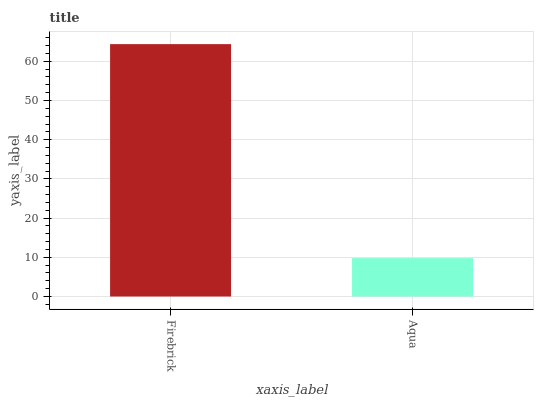Is Aqua the minimum?
Answer yes or no. Yes. Is Firebrick the maximum?
Answer yes or no. Yes. Is Aqua the maximum?
Answer yes or no. No. Is Firebrick greater than Aqua?
Answer yes or no. Yes. Is Aqua less than Firebrick?
Answer yes or no. Yes. Is Aqua greater than Firebrick?
Answer yes or no. No. Is Firebrick less than Aqua?
Answer yes or no. No. Is Firebrick the high median?
Answer yes or no. Yes. Is Aqua the low median?
Answer yes or no. Yes. Is Aqua the high median?
Answer yes or no. No. Is Firebrick the low median?
Answer yes or no. No. 